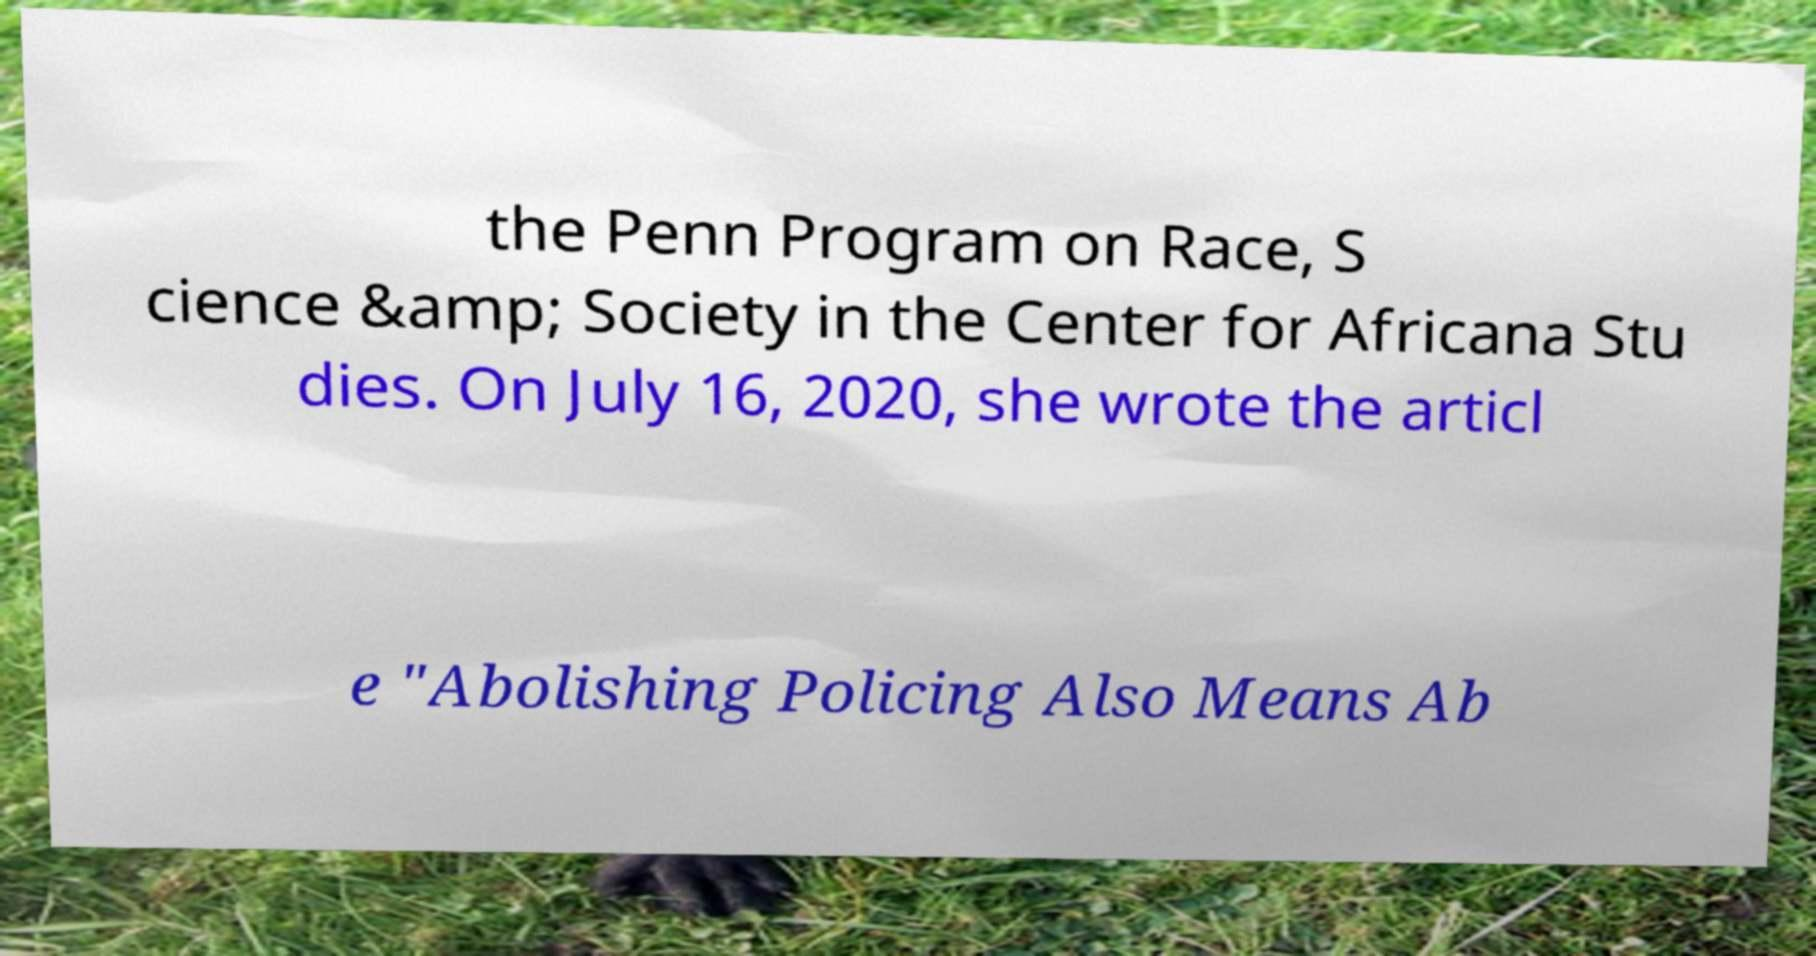Please read and relay the text visible in this image. What does it say? the Penn Program on Race, S cience &amp; Society in the Center for Africana Stu dies. On July 16, 2020, she wrote the articl e "Abolishing Policing Also Means Ab 